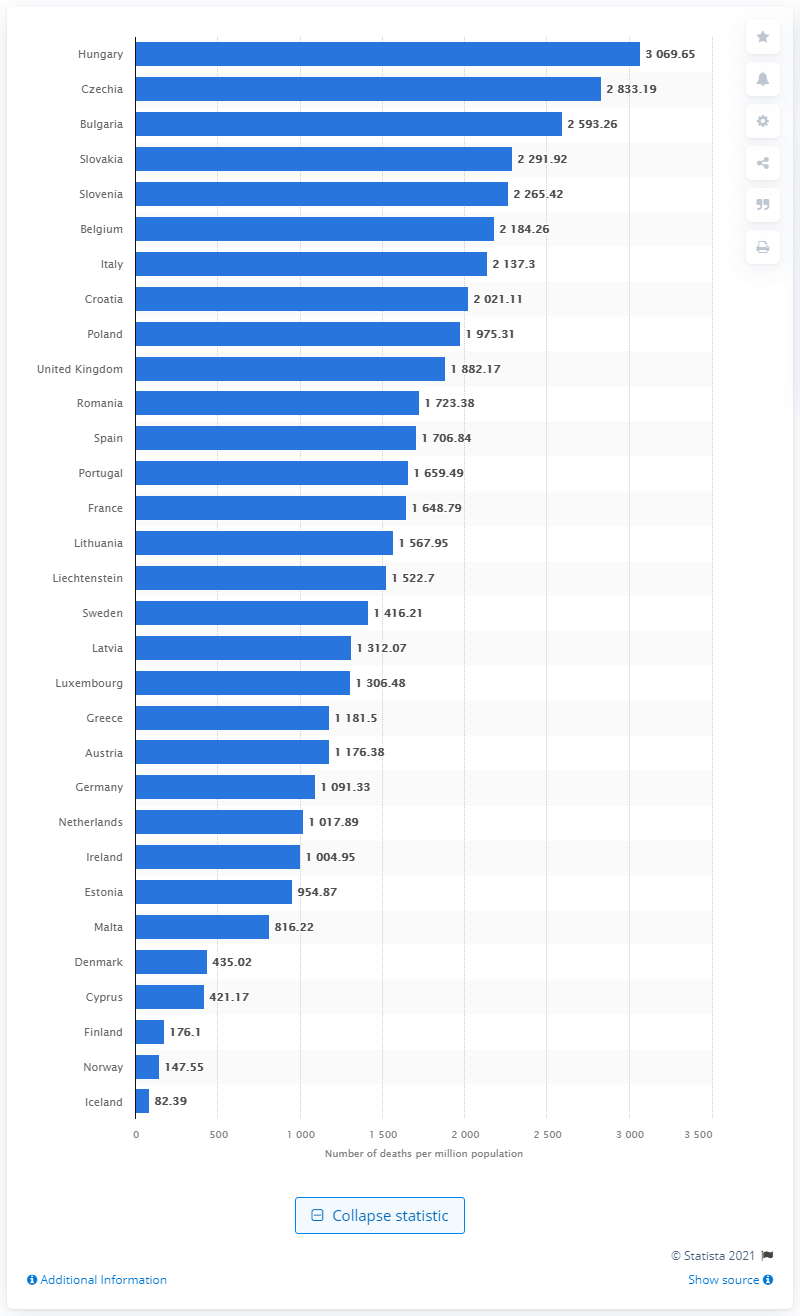Give some essential details in this illustration. The country with the highest death rate from COVID-19 in Europe is Czechia. 